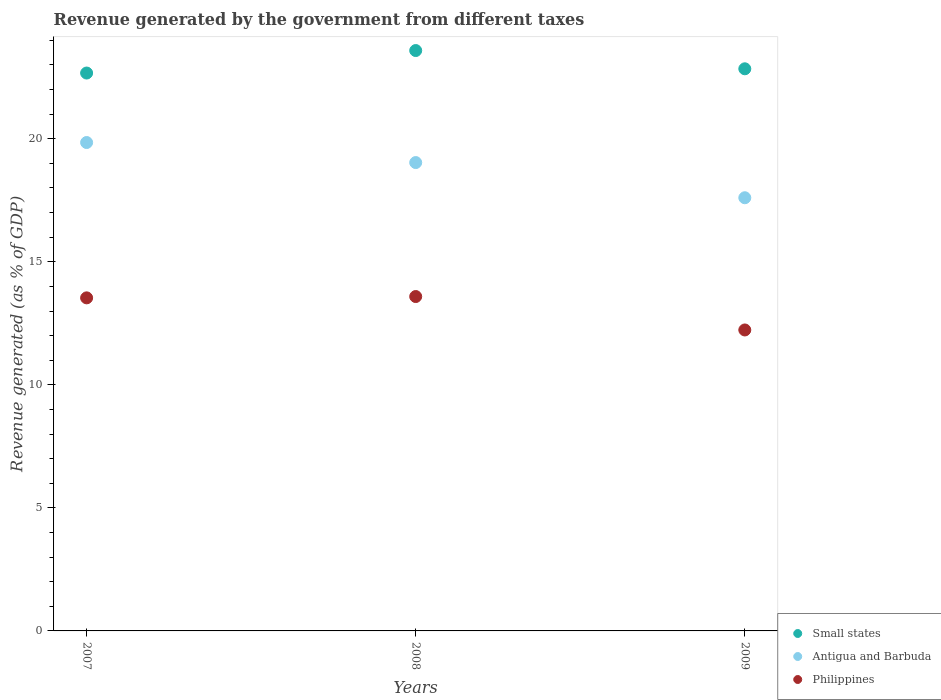How many different coloured dotlines are there?
Your response must be concise. 3. Is the number of dotlines equal to the number of legend labels?
Your response must be concise. Yes. What is the revenue generated by the government in Antigua and Barbuda in 2009?
Offer a terse response. 17.6. Across all years, what is the maximum revenue generated by the government in Antigua and Barbuda?
Your answer should be very brief. 19.85. Across all years, what is the minimum revenue generated by the government in Philippines?
Your response must be concise. 12.23. In which year was the revenue generated by the government in Philippines minimum?
Provide a succinct answer. 2009. What is the total revenue generated by the government in Small states in the graph?
Offer a very short reply. 69.1. What is the difference between the revenue generated by the government in Philippines in 2007 and that in 2009?
Keep it short and to the point. 1.3. What is the difference between the revenue generated by the government in Small states in 2009 and the revenue generated by the government in Antigua and Barbuda in 2008?
Your answer should be compact. 3.81. What is the average revenue generated by the government in Philippines per year?
Offer a very short reply. 13.12. In the year 2007, what is the difference between the revenue generated by the government in Antigua and Barbuda and revenue generated by the government in Small states?
Your response must be concise. -2.82. What is the ratio of the revenue generated by the government in Philippines in 2007 to that in 2008?
Offer a terse response. 1. Is the revenue generated by the government in Philippines in 2007 less than that in 2008?
Provide a succinct answer. Yes. Is the difference between the revenue generated by the government in Antigua and Barbuda in 2008 and 2009 greater than the difference between the revenue generated by the government in Small states in 2008 and 2009?
Offer a terse response. Yes. What is the difference between the highest and the second highest revenue generated by the government in Small states?
Your answer should be compact. 0.74. What is the difference between the highest and the lowest revenue generated by the government in Small states?
Provide a succinct answer. 0.91. Is the sum of the revenue generated by the government in Antigua and Barbuda in 2007 and 2008 greater than the maximum revenue generated by the government in Philippines across all years?
Provide a short and direct response. Yes. Is it the case that in every year, the sum of the revenue generated by the government in Small states and revenue generated by the government in Philippines  is greater than the revenue generated by the government in Antigua and Barbuda?
Your response must be concise. Yes. Is the revenue generated by the government in Small states strictly less than the revenue generated by the government in Antigua and Barbuda over the years?
Give a very brief answer. No. How many dotlines are there?
Keep it short and to the point. 3. How many years are there in the graph?
Provide a succinct answer. 3. Does the graph contain any zero values?
Your response must be concise. No. Does the graph contain grids?
Your answer should be compact. No. Where does the legend appear in the graph?
Your answer should be very brief. Bottom right. How many legend labels are there?
Your response must be concise. 3. How are the legend labels stacked?
Provide a short and direct response. Vertical. What is the title of the graph?
Keep it short and to the point. Revenue generated by the government from different taxes. Does "Trinidad and Tobago" appear as one of the legend labels in the graph?
Make the answer very short. No. What is the label or title of the Y-axis?
Keep it short and to the point. Revenue generated (as % of GDP). What is the Revenue generated (as % of GDP) in Small states in 2007?
Keep it short and to the point. 22.67. What is the Revenue generated (as % of GDP) in Antigua and Barbuda in 2007?
Your response must be concise. 19.85. What is the Revenue generated (as % of GDP) in Philippines in 2007?
Keep it short and to the point. 13.54. What is the Revenue generated (as % of GDP) of Small states in 2008?
Ensure brevity in your answer.  23.59. What is the Revenue generated (as % of GDP) of Antigua and Barbuda in 2008?
Ensure brevity in your answer.  19.03. What is the Revenue generated (as % of GDP) of Philippines in 2008?
Your answer should be compact. 13.59. What is the Revenue generated (as % of GDP) in Small states in 2009?
Your answer should be very brief. 22.84. What is the Revenue generated (as % of GDP) of Antigua and Barbuda in 2009?
Offer a terse response. 17.6. What is the Revenue generated (as % of GDP) in Philippines in 2009?
Your response must be concise. 12.23. Across all years, what is the maximum Revenue generated (as % of GDP) of Small states?
Ensure brevity in your answer.  23.59. Across all years, what is the maximum Revenue generated (as % of GDP) in Antigua and Barbuda?
Provide a succinct answer. 19.85. Across all years, what is the maximum Revenue generated (as % of GDP) in Philippines?
Your response must be concise. 13.59. Across all years, what is the minimum Revenue generated (as % of GDP) in Small states?
Give a very brief answer. 22.67. Across all years, what is the minimum Revenue generated (as % of GDP) in Antigua and Barbuda?
Provide a short and direct response. 17.6. Across all years, what is the minimum Revenue generated (as % of GDP) in Philippines?
Give a very brief answer. 12.23. What is the total Revenue generated (as % of GDP) of Small states in the graph?
Your answer should be very brief. 69.1. What is the total Revenue generated (as % of GDP) in Antigua and Barbuda in the graph?
Offer a terse response. 56.48. What is the total Revenue generated (as % of GDP) of Philippines in the graph?
Your answer should be very brief. 39.35. What is the difference between the Revenue generated (as % of GDP) in Small states in 2007 and that in 2008?
Ensure brevity in your answer.  -0.91. What is the difference between the Revenue generated (as % of GDP) in Antigua and Barbuda in 2007 and that in 2008?
Offer a terse response. 0.81. What is the difference between the Revenue generated (as % of GDP) of Philippines in 2007 and that in 2008?
Give a very brief answer. -0.05. What is the difference between the Revenue generated (as % of GDP) of Small states in 2007 and that in 2009?
Offer a very short reply. -0.17. What is the difference between the Revenue generated (as % of GDP) in Antigua and Barbuda in 2007 and that in 2009?
Provide a short and direct response. 2.24. What is the difference between the Revenue generated (as % of GDP) of Philippines in 2007 and that in 2009?
Ensure brevity in your answer.  1.3. What is the difference between the Revenue generated (as % of GDP) in Small states in 2008 and that in 2009?
Your answer should be compact. 0.74. What is the difference between the Revenue generated (as % of GDP) in Antigua and Barbuda in 2008 and that in 2009?
Your response must be concise. 1.43. What is the difference between the Revenue generated (as % of GDP) of Philippines in 2008 and that in 2009?
Ensure brevity in your answer.  1.36. What is the difference between the Revenue generated (as % of GDP) of Small states in 2007 and the Revenue generated (as % of GDP) of Antigua and Barbuda in 2008?
Provide a short and direct response. 3.64. What is the difference between the Revenue generated (as % of GDP) in Small states in 2007 and the Revenue generated (as % of GDP) in Philippines in 2008?
Your answer should be compact. 9.08. What is the difference between the Revenue generated (as % of GDP) of Antigua and Barbuda in 2007 and the Revenue generated (as % of GDP) of Philippines in 2008?
Give a very brief answer. 6.26. What is the difference between the Revenue generated (as % of GDP) in Small states in 2007 and the Revenue generated (as % of GDP) in Antigua and Barbuda in 2009?
Offer a terse response. 5.07. What is the difference between the Revenue generated (as % of GDP) of Small states in 2007 and the Revenue generated (as % of GDP) of Philippines in 2009?
Offer a terse response. 10.44. What is the difference between the Revenue generated (as % of GDP) in Antigua and Barbuda in 2007 and the Revenue generated (as % of GDP) in Philippines in 2009?
Your response must be concise. 7.62. What is the difference between the Revenue generated (as % of GDP) in Small states in 2008 and the Revenue generated (as % of GDP) in Antigua and Barbuda in 2009?
Offer a terse response. 5.98. What is the difference between the Revenue generated (as % of GDP) of Small states in 2008 and the Revenue generated (as % of GDP) of Philippines in 2009?
Ensure brevity in your answer.  11.36. What is the difference between the Revenue generated (as % of GDP) of Antigua and Barbuda in 2008 and the Revenue generated (as % of GDP) of Philippines in 2009?
Your response must be concise. 6.8. What is the average Revenue generated (as % of GDP) in Small states per year?
Your response must be concise. 23.03. What is the average Revenue generated (as % of GDP) of Antigua and Barbuda per year?
Offer a very short reply. 18.83. What is the average Revenue generated (as % of GDP) of Philippines per year?
Offer a very short reply. 13.12. In the year 2007, what is the difference between the Revenue generated (as % of GDP) of Small states and Revenue generated (as % of GDP) of Antigua and Barbuda?
Ensure brevity in your answer.  2.82. In the year 2007, what is the difference between the Revenue generated (as % of GDP) in Small states and Revenue generated (as % of GDP) in Philippines?
Your response must be concise. 9.14. In the year 2007, what is the difference between the Revenue generated (as % of GDP) in Antigua and Barbuda and Revenue generated (as % of GDP) in Philippines?
Provide a short and direct response. 6.31. In the year 2008, what is the difference between the Revenue generated (as % of GDP) of Small states and Revenue generated (as % of GDP) of Antigua and Barbuda?
Provide a succinct answer. 4.55. In the year 2008, what is the difference between the Revenue generated (as % of GDP) in Small states and Revenue generated (as % of GDP) in Philippines?
Give a very brief answer. 10. In the year 2008, what is the difference between the Revenue generated (as % of GDP) of Antigua and Barbuda and Revenue generated (as % of GDP) of Philippines?
Your answer should be very brief. 5.44. In the year 2009, what is the difference between the Revenue generated (as % of GDP) in Small states and Revenue generated (as % of GDP) in Antigua and Barbuda?
Your answer should be compact. 5.24. In the year 2009, what is the difference between the Revenue generated (as % of GDP) of Small states and Revenue generated (as % of GDP) of Philippines?
Keep it short and to the point. 10.61. In the year 2009, what is the difference between the Revenue generated (as % of GDP) in Antigua and Barbuda and Revenue generated (as % of GDP) in Philippines?
Offer a very short reply. 5.37. What is the ratio of the Revenue generated (as % of GDP) in Small states in 2007 to that in 2008?
Keep it short and to the point. 0.96. What is the ratio of the Revenue generated (as % of GDP) of Antigua and Barbuda in 2007 to that in 2008?
Your answer should be compact. 1.04. What is the ratio of the Revenue generated (as % of GDP) of Philippines in 2007 to that in 2008?
Give a very brief answer. 1. What is the ratio of the Revenue generated (as % of GDP) in Antigua and Barbuda in 2007 to that in 2009?
Give a very brief answer. 1.13. What is the ratio of the Revenue generated (as % of GDP) of Philippines in 2007 to that in 2009?
Your response must be concise. 1.11. What is the ratio of the Revenue generated (as % of GDP) of Small states in 2008 to that in 2009?
Your response must be concise. 1.03. What is the ratio of the Revenue generated (as % of GDP) in Antigua and Barbuda in 2008 to that in 2009?
Your answer should be very brief. 1.08. What is the difference between the highest and the second highest Revenue generated (as % of GDP) in Small states?
Your response must be concise. 0.74. What is the difference between the highest and the second highest Revenue generated (as % of GDP) in Antigua and Barbuda?
Your response must be concise. 0.81. What is the difference between the highest and the second highest Revenue generated (as % of GDP) of Philippines?
Provide a short and direct response. 0.05. What is the difference between the highest and the lowest Revenue generated (as % of GDP) of Small states?
Provide a succinct answer. 0.91. What is the difference between the highest and the lowest Revenue generated (as % of GDP) of Antigua and Barbuda?
Provide a succinct answer. 2.24. What is the difference between the highest and the lowest Revenue generated (as % of GDP) of Philippines?
Your answer should be very brief. 1.36. 